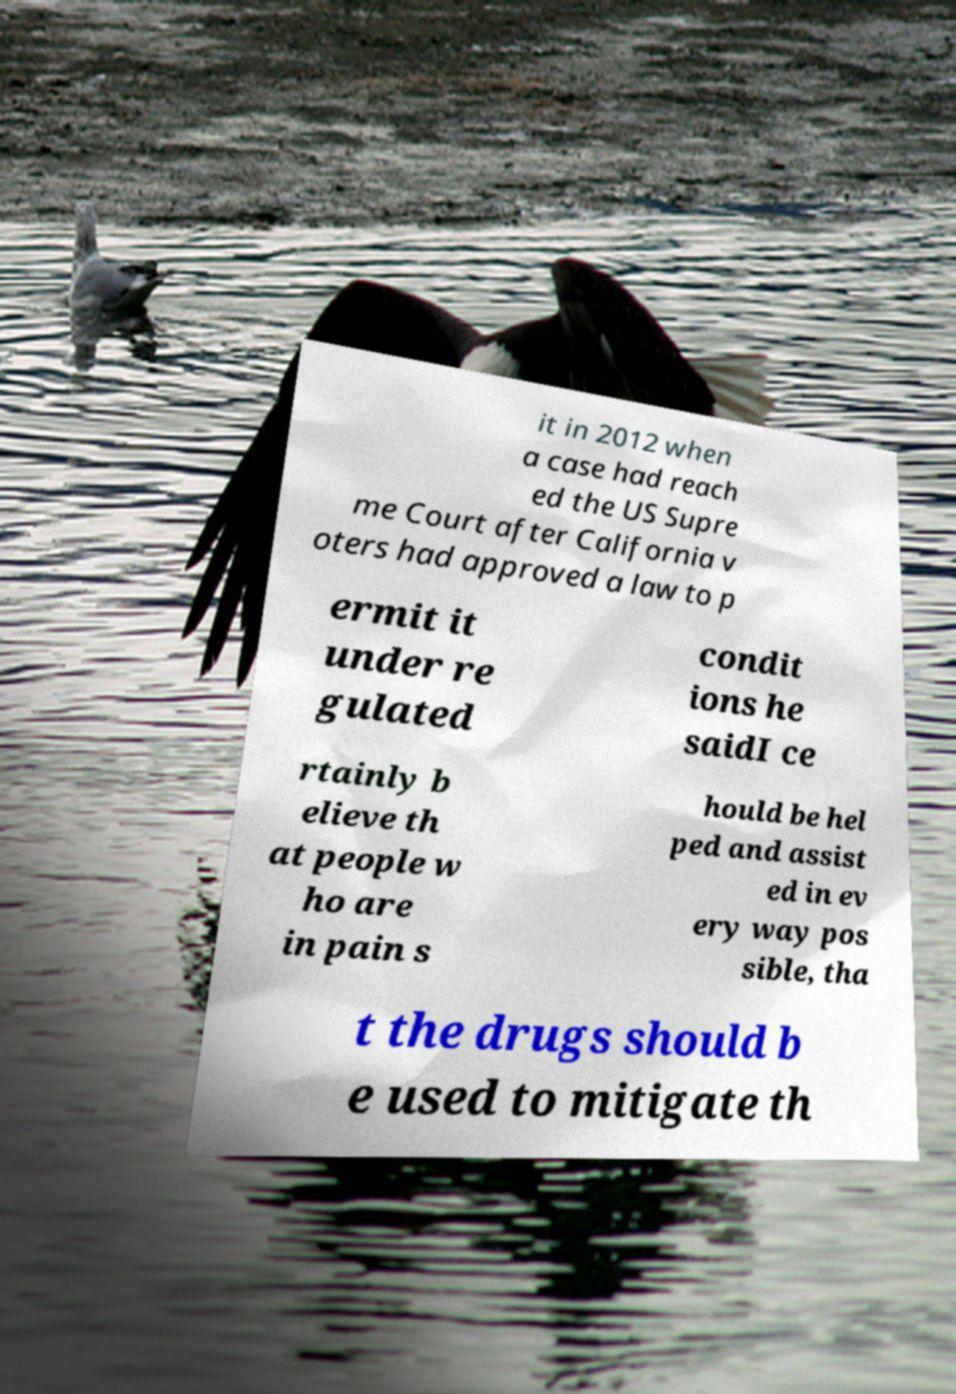Could you assist in decoding the text presented in this image and type it out clearly? it in 2012 when a case had reach ed the US Supre me Court after California v oters had approved a law to p ermit it under re gulated condit ions he saidI ce rtainly b elieve th at people w ho are in pain s hould be hel ped and assist ed in ev ery way pos sible, tha t the drugs should b e used to mitigate th 